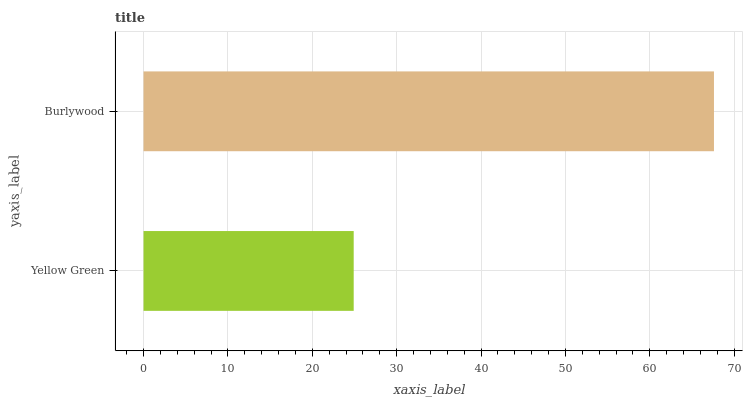Is Yellow Green the minimum?
Answer yes or no. Yes. Is Burlywood the maximum?
Answer yes or no. Yes. Is Burlywood the minimum?
Answer yes or no. No. Is Burlywood greater than Yellow Green?
Answer yes or no. Yes. Is Yellow Green less than Burlywood?
Answer yes or no. Yes. Is Yellow Green greater than Burlywood?
Answer yes or no. No. Is Burlywood less than Yellow Green?
Answer yes or no. No. Is Burlywood the high median?
Answer yes or no. Yes. Is Yellow Green the low median?
Answer yes or no. Yes. Is Yellow Green the high median?
Answer yes or no. No. Is Burlywood the low median?
Answer yes or no. No. 